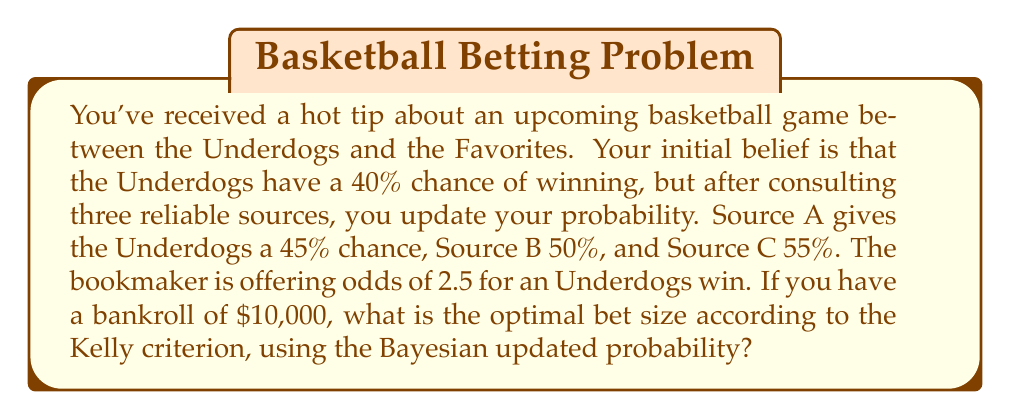Give your solution to this math problem. To solve this problem, we'll follow these steps:

1. Calculate the Bayesian updated probability
2. Determine the edge based on the updated probability and bookmaker odds
3. Apply the Kelly criterion to find the optimal bet size

Step 1: Bayesian Updated Probability

We start with a prior probability of 40% and update it with three new pieces of information. We can use a simple average to combine these probabilities:

$$ P(\text{Underdogs win}) = \frac{40\% + 45\% + 50\% + 55\%}{4} = 47.5\% = 0.475 $$

Step 2: Determine the Edge

The bookmaker odds of 2.5 imply a probability of:

$$ P(\text{bookmaker}) = \frac{1}{2.5} = 0.4 $$

Our edge is the difference between our probability and the bookmaker's implied probability:

$$ \text{Edge} = 0.475 - 0.4 = 0.075 $$

Step 3: Apply Kelly Criterion

The Kelly criterion formula is:

$$ f = \frac{bp - q}{b} $$

Where:
$f$ = fraction of bankroll to bet
$b$ = net odds received on the bet (odds - 1)
$p$ = probability of winning
$q$ = probability of losing (1 - p)

In our case:
$b = 2.5 - 1 = 1.5$
$p = 0.475$
$q = 1 - 0.475 = 0.525$

Plugging these values into the Kelly formula:

$$ f = \frac{1.5 * 0.475 - 0.525}{1.5} = 0.1 $$

This means we should bet 10% of our bankroll. With a $10,000 bankroll, the optimal bet size is:

$$ 10,000 * 0.1 = $1,000 $$
Answer: The optimal bet size according to the Kelly criterion, using the Bayesian updated probability, is $1,000. 